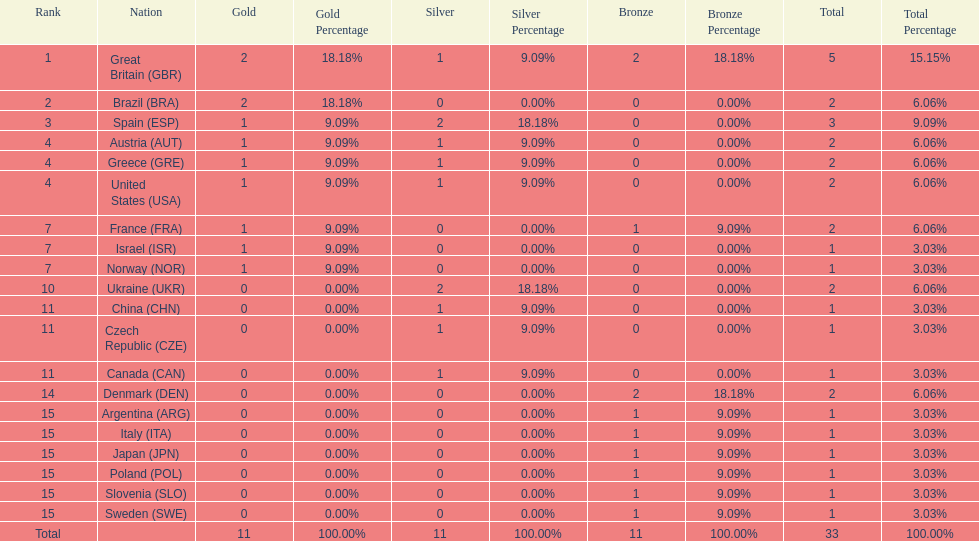Which country won the most medals total? Great Britain (GBR). 